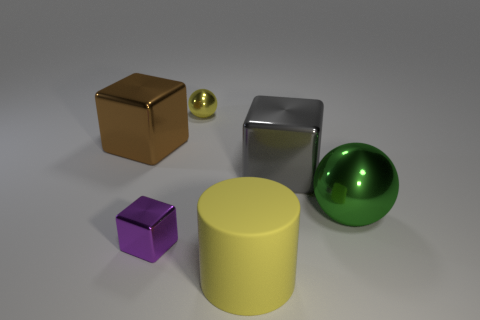There is a large thing that is the same color as the small ball; what is its material?
Provide a short and direct response. Rubber. What number of small metal balls are the same color as the large rubber cylinder?
Your answer should be compact. 1. There is a big ball that is made of the same material as the purple object; what color is it?
Make the answer very short. Green. Is there a metal ball of the same size as the brown block?
Offer a very short reply. Yes. Is the number of brown cubes right of the yellow cylinder greater than the number of rubber things behind the large gray block?
Offer a terse response. No. Do the cube to the right of the big matte thing and the yellow thing that is behind the brown shiny thing have the same material?
Your response must be concise. Yes. What is the shape of the thing that is the same size as the purple block?
Provide a succinct answer. Sphere. Is there another metallic object that has the same shape as the brown shiny object?
Make the answer very short. Yes. There is a sphere behind the brown metal object; is its color the same as the large cube that is to the left of the big yellow rubber thing?
Your response must be concise. No. Are there any large cubes in front of the large gray block?
Ensure brevity in your answer.  No. 